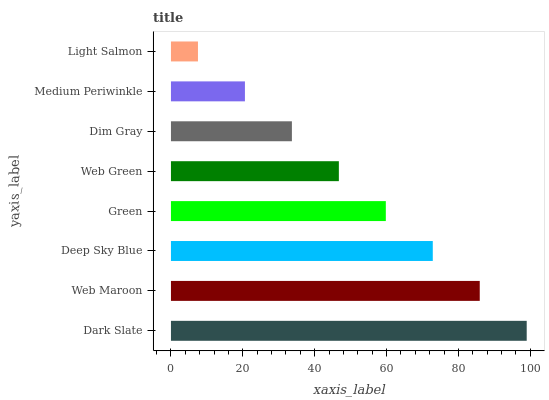Is Light Salmon the minimum?
Answer yes or no. Yes. Is Dark Slate the maximum?
Answer yes or no. Yes. Is Web Maroon the minimum?
Answer yes or no. No. Is Web Maroon the maximum?
Answer yes or no. No. Is Dark Slate greater than Web Maroon?
Answer yes or no. Yes. Is Web Maroon less than Dark Slate?
Answer yes or no. Yes. Is Web Maroon greater than Dark Slate?
Answer yes or no. No. Is Dark Slate less than Web Maroon?
Answer yes or no. No. Is Green the high median?
Answer yes or no. Yes. Is Web Green the low median?
Answer yes or no. Yes. Is Web Green the high median?
Answer yes or no. No. Is Dark Slate the low median?
Answer yes or no. No. 